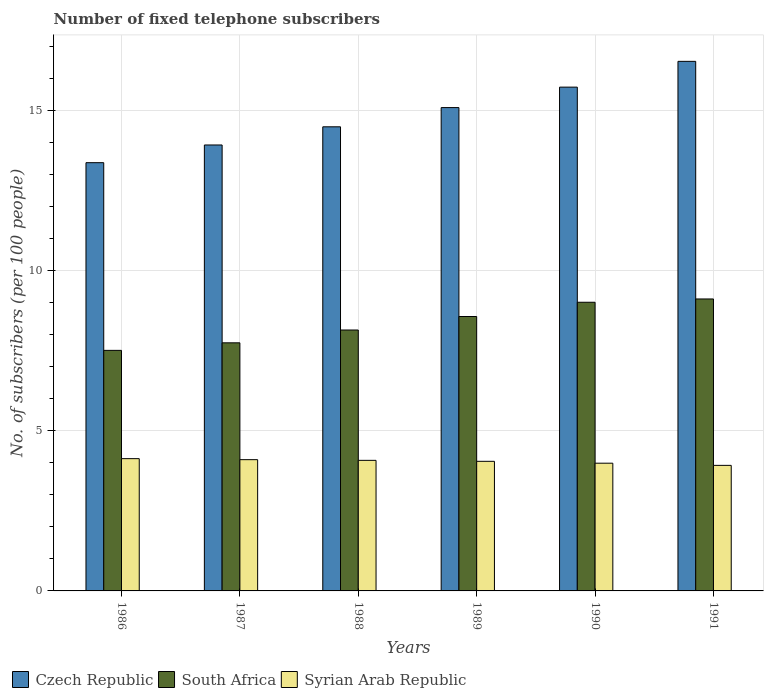How many groups of bars are there?
Provide a short and direct response. 6. What is the number of fixed telephone subscribers in Syrian Arab Republic in 1988?
Your answer should be compact. 4.08. Across all years, what is the maximum number of fixed telephone subscribers in Syrian Arab Republic?
Offer a terse response. 4.13. Across all years, what is the minimum number of fixed telephone subscribers in South Africa?
Ensure brevity in your answer.  7.51. In which year was the number of fixed telephone subscribers in Syrian Arab Republic maximum?
Your answer should be very brief. 1986. In which year was the number of fixed telephone subscribers in South Africa minimum?
Offer a terse response. 1986. What is the total number of fixed telephone subscribers in Syrian Arab Republic in the graph?
Your answer should be very brief. 24.25. What is the difference between the number of fixed telephone subscribers in Syrian Arab Republic in 1987 and that in 1989?
Offer a very short reply. 0.05. What is the difference between the number of fixed telephone subscribers in Czech Republic in 1989 and the number of fixed telephone subscribers in Syrian Arab Republic in 1990?
Your response must be concise. 11.1. What is the average number of fixed telephone subscribers in South Africa per year?
Make the answer very short. 8.35. In the year 1990, what is the difference between the number of fixed telephone subscribers in South Africa and number of fixed telephone subscribers in Czech Republic?
Offer a very short reply. -6.71. What is the ratio of the number of fixed telephone subscribers in Syrian Arab Republic in 1987 to that in 1988?
Provide a short and direct response. 1.01. What is the difference between the highest and the second highest number of fixed telephone subscribers in Czech Republic?
Offer a terse response. 0.8. What is the difference between the highest and the lowest number of fixed telephone subscribers in Czech Republic?
Make the answer very short. 3.16. In how many years, is the number of fixed telephone subscribers in Czech Republic greater than the average number of fixed telephone subscribers in Czech Republic taken over all years?
Provide a succinct answer. 3. What does the 1st bar from the left in 1991 represents?
Make the answer very short. Czech Republic. What does the 2nd bar from the right in 1988 represents?
Offer a terse response. South Africa. Is it the case that in every year, the sum of the number of fixed telephone subscribers in South Africa and number of fixed telephone subscribers in Syrian Arab Republic is greater than the number of fixed telephone subscribers in Czech Republic?
Provide a short and direct response. No. How many bars are there?
Give a very brief answer. 18. How many years are there in the graph?
Ensure brevity in your answer.  6. What is the difference between two consecutive major ticks on the Y-axis?
Keep it short and to the point. 5. Are the values on the major ticks of Y-axis written in scientific E-notation?
Ensure brevity in your answer.  No. Does the graph contain any zero values?
Offer a very short reply. No. Does the graph contain grids?
Your response must be concise. Yes. How many legend labels are there?
Provide a short and direct response. 3. What is the title of the graph?
Give a very brief answer. Number of fixed telephone subscribers. Does "Poland" appear as one of the legend labels in the graph?
Provide a short and direct response. No. What is the label or title of the X-axis?
Offer a terse response. Years. What is the label or title of the Y-axis?
Keep it short and to the point. No. of subscribers (per 100 people). What is the No. of subscribers (per 100 people) of Czech Republic in 1986?
Your response must be concise. 13.37. What is the No. of subscribers (per 100 people) of South Africa in 1986?
Provide a succinct answer. 7.51. What is the No. of subscribers (per 100 people) of Syrian Arab Republic in 1986?
Your answer should be very brief. 4.13. What is the No. of subscribers (per 100 people) of Czech Republic in 1987?
Your answer should be very brief. 13.92. What is the No. of subscribers (per 100 people) in South Africa in 1987?
Ensure brevity in your answer.  7.74. What is the No. of subscribers (per 100 people) of Syrian Arab Republic in 1987?
Provide a short and direct response. 4.1. What is the No. of subscribers (per 100 people) in Czech Republic in 1988?
Provide a short and direct response. 14.49. What is the No. of subscribers (per 100 people) of South Africa in 1988?
Your answer should be very brief. 8.14. What is the No. of subscribers (per 100 people) in Syrian Arab Republic in 1988?
Your answer should be compact. 4.08. What is the No. of subscribers (per 100 people) of Czech Republic in 1989?
Provide a succinct answer. 15.09. What is the No. of subscribers (per 100 people) in South Africa in 1989?
Keep it short and to the point. 8.56. What is the No. of subscribers (per 100 people) of Syrian Arab Republic in 1989?
Ensure brevity in your answer.  4.05. What is the No. of subscribers (per 100 people) in Czech Republic in 1990?
Your answer should be compact. 15.72. What is the No. of subscribers (per 100 people) in South Africa in 1990?
Your answer should be compact. 9.01. What is the No. of subscribers (per 100 people) of Syrian Arab Republic in 1990?
Your response must be concise. 3.99. What is the No. of subscribers (per 100 people) of Czech Republic in 1991?
Your response must be concise. 16.53. What is the No. of subscribers (per 100 people) of South Africa in 1991?
Give a very brief answer. 9.11. What is the No. of subscribers (per 100 people) in Syrian Arab Republic in 1991?
Provide a succinct answer. 3.92. Across all years, what is the maximum No. of subscribers (per 100 people) in Czech Republic?
Give a very brief answer. 16.53. Across all years, what is the maximum No. of subscribers (per 100 people) in South Africa?
Your answer should be compact. 9.11. Across all years, what is the maximum No. of subscribers (per 100 people) of Syrian Arab Republic?
Make the answer very short. 4.13. Across all years, what is the minimum No. of subscribers (per 100 people) in Czech Republic?
Make the answer very short. 13.37. Across all years, what is the minimum No. of subscribers (per 100 people) of South Africa?
Give a very brief answer. 7.51. Across all years, what is the minimum No. of subscribers (per 100 people) of Syrian Arab Republic?
Offer a very short reply. 3.92. What is the total No. of subscribers (per 100 people) in Czech Republic in the graph?
Give a very brief answer. 89.11. What is the total No. of subscribers (per 100 people) in South Africa in the graph?
Offer a terse response. 50.08. What is the total No. of subscribers (per 100 people) in Syrian Arab Republic in the graph?
Make the answer very short. 24.25. What is the difference between the No. of subscribers (per 100 people) in Czech Republic in 1986 and that in 1987?
Give a very brief answer. -0.55. What is the difference between the No. of subscribers (per 100 people) of South Africa in 1986 and that in 1987?
Make the answer very short. -0.24. What is the difference between the No. of subscribers (per 100 people) of Syrian Arab Republic in 1986 and that in 1987?
Provide a short and direct response. 0.03. What is the difference between the No. of subscribers (per 100 people) in Czech Republic in 1986 and that in 1988?
Your answer should be compact. -1.12. What is the difference between the No. of subscribers (per 100 people) in South Africa in 1986 and that in 1988?
Keep it short and to the point. -0.64. What is the difference between the No. of subscribers (per 100 people) of Syrian Arab Republic in 1986 and that in 1988?
Offer a terse response. 0.05. What is the difference between the No. of subscribers (per 100 people) of Czech Republic in 1986 and that in 1989?
Provide a succinct answer. -1.72. What is the difference between the No. of subscribers (per 100 people) of South Africa in 1986 and that in 1989?
Provide a succinct answer. -1.06. What is the difference between the No. of subscribers (per 100 people) of Syrian Arab Republic in 1986 and that in 1989?
Provide a succinct answer. 0.08. What is the difference between the No. of subscribers (per 100 people) in Czech Republic in 1986 and that in 1990?
Ensure brevity in your answer.  -2.36. What is the difference between the No. of subscribers (per 100 people) of South Africa in 1986 and that in 1990?
Your response must be concise. -1.5. What is the difference between the No. of subscribers (per 100 people) in Syrian Arab Republic in 1986 and that in 1990?
Offer a very short reply. 0.14. What is the difference between the No. of subscribers (per 100 people) of Czech Republic in 1986 and that in 1991?
Your answer should be very brief. -3.16. What is the difference between the No. of subscribers (per 100 people) of South Africa in 1986 and that in 1991?
Your answer should be very brief. -1.6. What is the difference between the No. of subscribers (per 100 people) in Syrian Arab Republic in 1986 and that in 1991?
Your answer should be compact. 0.21. What is the difference between the No. of subscribers (per 100 people) of Czech Republic in 1987 and that in 1988?
Offer a terse response. -0.57. What is the difference between the No. of subscribers (per 100 people) in South Africa in 1987 and that in 1988?
Make the answer very short. -0.4. What is the difference between the No. of subscribers (per 100 people) in Syrian Arab Republic in 1987 and that in 1988?
Your response must be concise. 0.02. What is the difference between the No. of subscribers (per 100 people) of Czech Republic in 1987 and that in 1989?
Your response must be concise. -1.17. What is the difference between the No. of subscribers (per 100 people) in South Africa in 1987 and that in 1989?
Provide a succinct answer. -0.82. What is the difference between the No. of subscribers (per 100 people) in Syrian Arab Republic in 1987 and that in 1989?
Keep it short and to the point. 0.05. What is the difference between the No. of subscribers (per 100 people) of Czech Republic in 1987 and that in 1990?
Ensure brevity in your answer.  -1.81. What is the difference between the No. of subscribers (per 100 people) of South Africa in 1987 and that in 1990?
Give a very brief answer. -1.27. What is the difference between the No. of subscribers (per 100 people) in Syrian Arab Republic in 1987 and that in 1990?
Make the answer very short. 0.11. What is the difference between the No. of subscribers (per 100 people) in Czech Republic in 1987 and that in 1991?
Keep it short and to the point. -2.61. What is the difference between the No. of subscribers (per 100 people) in South Africa in 1987 and that in 1991?
Your answer should be very brief. -1.37. What is the difference between the No. of subscribers (per 100 people) of Syrian Arab Republic in 1987 and that in 1991?
Make the answer very short. 0.18. What is the difference between the No. of subscribers (per 100 people) of South Africa in 1988 and that in 1989?
Provide a succinct answer. -0.42. What is the difference between the No. of subscribers (per 100 people) in Syrian Arab Republic in 1988 and that in 1989?
Your response must be concise. 0.03. What is the difference between the No. of subscribers (per 100 people) of Czech Republic in 1988 and that in 1990?
Offer a terse response. -1.24. What is the difference between the No. of subscribers (per 100 people) of South Africa in 1988 and that in 1990?
Keep it short and to the point. -0.87. What is the difference between the No. of subscribers (per 100 people) of Syrian Arab Republic in 1988 and that in 1990?
Your answer should be very brief. 0.09. What is the difference between the No. of subscribers (per 100 people) of Czech Republic in 1988 and that in 1991?
Make the answer very short. -2.04. What is the difference between the No. of subscribers (per 100 people) in South Africa in 1988 and that in 1991?
Offer a very short reply. -0.97. What is the difference between the No. of subscribers (per 100 people) in Syrian Arab Republic in 1988 and that in 1991?
Offer a terse response. 0.16. What is the difference between the No. of subscribers (per 100 people) of Czech Republic in 1989 and that in 1990?
Your answer should be very brief. -0.64. What is the difference between the No. of subscribers (per 100 people) in South Africa in 1989 and that in 1990?
Offer a terse response. -0.44. What is the difference between the No. of subscribers (per 100 people) of Syrian Arab Republic in 1989 and that in 1990?
Ensure brevity in your answer.  0.06. What is the difference between the No. of subscribers (per 100 people) of Czech Republic in 1989 and that in 1991?
Ensure brevity in your answer.  -1.44. What is the difference between the No. of subscribers (per 100 people) in South Africa in 1989 and that in 1991?
Make the answer very short. -0.55. What is the difference between the No. of subscribers (per 100 people) of Syrian Arab Republic in 1989 and that in 1991?
Offer a very short reply. 0.13. What is the difference between the No. of subscribers (per 100 people) in Czech Republic in 1990 and that in 1991?
Provide a succinct answer. -0.8. What is the difference between the No. of subscribers (per 100 people) in South Africa in 1990 and that in 1991?
Offer a very short reply. -0.1. What is the difference between the No. of subscribers (per 100 people) of Syrian Arab Republic in 1990 and that in 1991?
Provide a short and direct response. 0.07. What is the difference between the No. of subscribers (per 100 people) of Czech Republic in 1986 and the No. of subscribers (per 100 people) of South Africa in 1987?
Your answer should be very brief. 5.62. What is the difference between the No. of subscribers (per 100 people) of Czech Republic in 1986 and the No. of subscribers (per 100 people) of Syrian Arab Republic in 1987?
Provide a short and direct response. 9.27. What is the difference between the No. of subscribers (per 100 people) of South Africa in 1986 and the No. of subscribers (per 100 people) of Syrian Arab Republic in 1987?
Your response must be concise. 3.41. What is the difference between the No. of subscribers (per 100 people) of Czech Republic in 1986 and the No. of subscribers (per 100 people) of South Africa in 1988?
Make the answer very short. 5.22. What is the difference between the No. of subscribers (per 100 people) of Czech Republic in 1986 and the No. of subscribers (per 100 people) of Syrian Arab Republic in 1988?
Ensure brevity in your answer.  9.29. What is the difference between the No. of subscribers (per 100 people) in South Africa in 1986 and the No. of subscribers (per 100 people) in Syrian Arab Republic in 1988?
Make the answer very short. 3.43. What is the difference between the No. of subscribers (per 100 people) of Czech Republic in 1986 and the No. of subscribers (per 100 people) of South Africa in 1989?
Make the answer very short. 4.8. What is the difference between the No. of subscribers (per 100 people) in Czech Republic in 1986 and the No. of subscribers (per 100 people) in Syrian Arab Republic in 1989?
Offer a terse response. 9.32. What is the difference between the No. of subscribers (per 100 people) of South Africa in 1986 and the No. of subscribers (per 100 people) of Syrian Arab Republic in 1989?
Offer a very short reply. 3.46. What is the difference between the No. of subscribers (per 100 people) in Czech Republic in 1986 and the No. of subscribers (per 100 people) in South Africa in 1990?
Your answer should be very brief. 4.36. What is the difference between the No. of subscribers (per 100 people) in Czech Republic in 1986 and the No. of subscribers (per 100 people) in Syrian Arab Republic in 1990?
Offer a very short reply. 9.38. What is the difference between the No. of subscribers (per 100 people) in South Africa in 1986 and the No. of subscribers (per 100 people) in Syrian Arab Republic in 1990?
Make the answer very short. 3.52. What is the difference between the No. of subscribers (per 100 people) of Czech Republic in 1986 and the No. of subscribers (per 100 people) of South Africa in 1991?
Give a very brief answer. 4.25. What is the difference between the No. of subscribers (per 100 people) in Czech Republic in 1986 and the No. of subscribers (per 100 people) in Syrian Arab Republic in 1991?
Keep it short and to the point. 9.45. What is the difference between the No. of subscribers (per 100 people) in South Africa in 1986 and the No. of subscribers (per 100 people) in Syrian Arab Republic in 1991?
Provide a succinct answer. 3.59. What is the difference between the No. of subscribers (per 100 people) of Czech Republic in 1987 and the No. of subscribers (per 100 people) of South Africa in 1988?
Offer a terse response. 5.78. What is the difference between the No. of subscribers (per 100 people) of Czech Republic in 1987 and the No. of subscribers (per 100 people) of Syrian Arab Republic in 1988?
Offer a very short reply. 9.84. What is the difference between the No. of subscribers (per 100 people) in South Africa in 1987 and the No. of subscribers (per 100 people) in Syrian Arab Republic in 1988?
Your answer should be very brief. 3.67. What is the difference between the No. of subscribers (per 100 people) of Czech Republic in 1987 and the No. of subscribers (per 100 people) of South Africa in 1989?
Give a very brief answer. 5.35. What is the difference between the No. of subscribers (per 100 people) in Czech Republic in 1987 and the No. of subscribers (per 100 people) in Syrian Arab Republic in 1989?
Make the answer very short. 9.87. What is the difference between the No. of subscribers (per 100 people) of South Africa in 1987 and the No. of subscribers (per 100 people) of Syrian Arab Republic in 1989?
Offer a very short reply. 3.7. What is the difference between the No. of subscribers (per 100 people) of Czech Republic in 1987 and the No. of subscribers (per 100 people) of South Africa in 1990?
Ensure brevity in your answer.  4.91. What is the difference between the No. of subscribers (per 100 people) in Czech Republic in 1987 and the No. of subscribers (per 100 people) in Syrian Arab Republic in 1990?
Provide a short and direct response. 9.93. What is the difference between the No. of subscribers (per 100 people) in South Africa in 1987 and the No. of subscribers (per 100 people) in Syrian Arab Republic in 1990?
Your response must be concise. 3.76. What is the difference between the No. of subscribers (per 100 people) of Czech Republic in 1987 and the No. of subscribers (per 100 people) of South Africa in 1991?
Give a very brief answer. 4.81. What is the difference between the No. of subscribers (per 100 people) of Czech Republic in 1987 and the No. of subscribers (per 100 people) of Syrian Arab Republic in 1991?
Ensure brevity in your answer.  10. What is the difference between the No. of subscribers (per 100 people) of South Africa in 1987 and the No. of subscribers (per 100 people) of Syrian Arab Republic in 1991?
Ensure brevity in your answer.  3.82. What is the difference between the No. of subscribers (per 100 people) in Czech Republic in 1988 and the No. of subscribers (per 100 people) in South Africa in 1989?
Offer a very short reply. 5.92. What is the difference between the No. of subscribers (per 100 people) of Czech Republic in 1988 and the No. of subscribers (per 100 people) of Syrian Arab Republic in 1989?
Keep it short and to the point. 10.44. What is the difference between the No. of subscribers (per 100 people) in South Africa in 1988 and the No. of subscribers (per 100 people) in Syrian Arab Republic in 1989?
Your answer should be very brief. 4.1. What is the difference between the No. of subscribers (per 100 people) of Czech Republic in 1988 and the No. of subscribers (per 100 people) of South Africa in 1990?
Provide a short and direct response. 5.48. What is the difference between the No. of subscribers (per 100 people) of Czech Republic in 1988 and the No. of subscribers (per 100 people) of Syrian Arab Republic in 1990?
Keep it short and to the point. 10.5. What is the difference between the No. of subscribers (per 100 people) of South Africa in 1988 and the No. of subscribers (per 100 people) of Syrian Arab Republic in 1990?
Offer a very short reply. 4.16. What is the difference between the No. of subscribers (per 100 people) of Czech Republic in 1988 and the No. of subscribers (per 100 people) of South Africa in 1991?
Your answer should be very brief. 5.37. What is the difference between the No. of subscribers (per 100 people) in Czech Republic in 1988 and the No. of subscribers (per 100 people) in Syrian Arab Republic in 1991?
Offer a very short reply. 10.57. What is the difference between the No. of subscribers (per 100 people) of South Africa in 1988 and the No. of subscribers (per 100 people) of Syrian Arab Republic in 1991?
Make the answer very short. 4.22. What is the difference between the No. of subscribers (per 100 people) of Czech Republic in 1989 and the No. of subscribers (per 100 people) of South Africa in 1990?
Give a very brief answer. 6.08. What is the difference between the No. of subscribers (per 100 people) of Czech Republic in 1989 and the No. of subscribers (per 100 people) of Syrian Arab Republic in 1990?
Give a very brief answer. 11.1. What is the difference between the No. of subscribers (per 100 people) in South Africa in 1989 and the No. of subscribers (per 100 people) in Syrian Arab Republic in 1990?
Offer a very short reply. 4.58. What is the difference between the No. of subscribers (per 100 people) in Czech Republic in 1989 and the No. of subscribers (per 100 people) in South Africa in 1991?
Your response must be concise. 5.97. What is the difference between the No. of subscribers (per 100 people) of Czech Republic in 1989 and the No. of subscribers (per 100 people) of Syrian Arab Republic in 1991?
Provide a succinct answer. 11.17. What is the difference between the No. of subscribers (per 100 people) in South Africa in 1989 and the No. of subscribers (per 100 people) in Syrian Arab Republic in 1991?
Provide a short and direct response. 4.65. What is the difference between the No. of subscribers (per 100 people) in Czech Republic in 1990 and the No. of subscribers (per 100 people) in South Africa in 1991?
Ensure brevity in your answer.  6.61. What is the difference between the No. of subscribers (per 100 people) in Czech Republic in 1990 and the No. of subscribers (per 100 people) in Syrian Arab Republic in 1991?
Keep it short and to the point. 11.81. What is the difference between the No. of subscribers (per 100 people) in South Africa in 1990 and the No. of subscribers (per 100 people) in Syrian Arab Republic in 1991?
Ensure brevity in your answer.  5.09. What is the average No. of subscribers (per 100 people) in Czech Republic per year?
Your answer should be compact. 14.85. What is the average No. of subscribers (per 100 people) in South Africa per year?
Make the answer very short. 8.35. What is the average No. of subscribers (per 100 people) of Syrian Arab Republic per year?
Your answer should be compact. 4.04. In the year 1986, what is the difference between the No. of subscribers (per 100 people) in Czech Republic and No. of subscribers (per 100 people) in South Africa?
Make the answer very short. 5.86. In the year 1986, what is the difference between the No. of subscribers (per 100 people) of Czech Republic and No. of subscribers (per 100 people) of Syrian Arab Republic?
Your answer should be very brief. 9.24. In the year 1986, what is the difference between the No. of subscribers (per 100 people) of South Africa and No. of subscribers (per 100 people) of Syrian Arab Republic?
Offer a terse response. 3.38. In the year 1987, what is the difference between the No. of subscribers (per 100 people) of Czech Republic and No. of subscribers (per 100 people) of South Africa?
Offer a terse response. 6.17. In the year 1987, what is the difference between the No. of subscribers (per 100 people) in Czech Republic and No. of subscribers (per 100 people) in Syrian Arab Republic?
Your answer should be very brief. 9.82. In the year 1987, what is the difference between the No. of subscribers (per 100 people) of South Africa and No. of subscribers (per 100 people) of Syrian Arab Republic?
Provide a short and direct response. 3.65. In the year 1988, what is the difference between the No. of subscribers (per 100 people) of Czech Republic and No. of subscribers (per 100 people) of South Africa?
Your answer should be very brief. 6.34. In the year 1988, what is the difference between the No. of subscribers (per 100 people) in Czech Republic and No. of subscribers (per 100 people) in Syrian Arab Republic?
Provide a succinct answer. 10.41. In the year 1988, what is the difference between the No. of subscribers (per 100 people) of South Africa and No. of subscribers (per 100 people) of Syrian Arab Republic?
Your response must be concise. 4.07. In the year 1989, what is the difference between the No. of subscribers (per 100 people) of Czech Republic and No. of subscribers (per 100 people) of South Africa?
Keep it short and to the point. 6.52. In the year 1989, what is the difference between the No. of subscribers (per 100 people) of Czech Republic and No. of subscribers (per 100 people) of Syrian Arab Republic?
Give a very brief answer. 11.04. In the year 1989, what is the difference between the No. of subscribers (per 100 people) of South Africa and No. of subscribers (per 100 people) of Syrian Arab Republic?
Keep it short and to the point. 4.52. In the year 1990, what is the difference between the No. of subscribers (per 100 people) of Czech Republic and No. of subscribers (per 100 people) of South Africa?
Your answer should be compact. 6.71. In the year 1990, what is the difference between the No. of subscribers (per 100 people) of Czech Republic and No. of subscribers (per 100 people) of Syrian Arab Republic?
Ensure brevity in your answer.  11.74. In the year 1990, what is the difference between the No. of subscribers (per 100 people) of South Africa and No. of subscribers (per 100 people) of Syrian Arab Republic?
Make the answer very short. 5.02. In the year 1991, what is the difference between the No. of subscribers (per 100 people) in Czech Republic and No. of subscribers (per 100 people) in South Africa?
Ensure brevity in your answer.  7.42. In the year 1991, what is the difference between the No. of subscribers (per 100 people) in Czech Republic and No. of subscribers (per 100 people) in Syrian Arab Republic?
Ensure brevity in your answer.  12.61. In the year 1991, what is the difference between the No. of subscribers (per 100 people) in South Africa and No. of subscribers (per 100 people) in Syrian Arab Republic?
Your answer should be compact. 5.19. What is the ratio of the No. of subscribers (per 100 people) of Czech Republic in 1986 to that in 1987?
Provide a succinct answer. 0.96. What is the ratio of the No. of subscribers (per 100 people) in South Africa in 1986 to that in 1987?
Your answer should be very brief. 0.97. What is the ratio of the No. of subscribers (per 100 people) in Syrian Arab Republic in 1986 to that in 1987?
Give a very brief answer. 1.01. What is the ratio of the No. of subscribers (per 100 people) in Czech Republic in 1986 to that in 1988?
Provide a succinct answer. 0.92. What is the ratio of the No. of subscribers (per 100 people) of South Africa in 1986 to that in 1988?
Your response must be concise. 0.92. What is the ratio of the No. of subscribers (per 100 people) of Syrian Arab Republic in 1986 to that in 1988?
Provide a succinct answer. 1.01. What is the ratio of the No. of subscribers (per 100 people) in Czech Republic in 1986 to that in 1989?
Offer a terse response. 0.89. What is the ratio of the No. of subscribers (per 100 people) of South Africa in 1986 to that in 1989?
Your answer should be very brief. 0.88. What is the ratio of the No. of subscribers (per 100 people) of Syrian Arab Republic in 1986 to that in 1989?
Keep it short and to the point. 1.02. What is the ratio of the No. of subscribers (per 100 people) in Czech Republic in 1986 to that in 1990?
Keep it short and to the point. 0.85. What is the ratio of the No. of subscribers (per 100 people) of South Africa in 1986 to that in 1990?
Ensure brevity in your answer.  0.83. What is the ratio of the No. of subscribers (per 100 people) in Syrian Arab Republic in 1986 to that in 1990?
Offer a terse response. 1.04. What is the ratio of the No. of subscribers (per 100 people) of Czech Republic in 1986 to that in 1991?
Provide a succinct answer. 0.81. What is the ratio of the No. of subscribers (per 100 people) in South Africa in 1986 to that in 1991?
Provide a short and direct response. 0.82. What is the ratio of the No. of subscribers (per 100 people) in Syrian Arab Republic in 1986 to that in 1991?
Your response must be concise. 1.05. What is the ratio of the No. of subscribers (per 100 people) of Czech Republic in 1987 to that in 1988?
Offer a very short reply. 0.96. What is the ratio of the No. of subscribers (per 100 people) of South Africa in 1987 to that in 1988?
Your answer should be very brief. 0.95. What is the ratio of the No. of subscribers (per 100 people) of Syrian Arab Republic in 1987 to that in 1988?
Make the answer very short. 1.01. What is the ratio of the No. of subscribers (per 100 people) in Czech Republic in 1987 to that in 1989?
Provide a short and direct response. 0.92. What is the ratio of the No. of subscribers (per 100 people) in South Africa in 1987 to that in 1989?
Keep it short and to the point. 0.9. What is the ratio of the No. of subscribers (per 100 people) in Syrian Arab Republic in 1987 to that in 1989?
Offer a terse response. 1.01. What is the ratio of the No. of subscribers (per 100 people) of Czech Republic in 1987 to that in 1990?
Your response must be concise. 0.89. What is the ratio of the No. of subscribers (per 100 people) of South Africa in 1987 to that in 1990?
Provide a succinct answer. 0.86. What is the ratio of the No. of subscribers (per 100 people) in Syrian Arab Republic in 1987 to that in 1990?
Give a very brief answer. 1.03. What is the ratio of the No. of subscribers (per 100 people) of Czech Republic in 1987 to that in 1991?
Your answer should be very brief. 0.84. What is the ratio of the No. of subscribers (per 100 people) in South Africa in 1987 to that in 1991?
Ensure brevity in your answer.  0.85. What is the ratio of the No. of subscribers (per 100 people) of Syrian Arab Republic in 1987 to that in 1991?
Your answer should be very brief. 1.05. What is the ratio of the No. of subscribers (per 100 people) in Czech Republic in 1988 to that in 1989?
Keep it short and to the point. 0.96. What is the ratio of the No. of subscribers (per 100 people) of South Africa in 1988 to that in 1989?
Give a very brief answer. 0.95. What is the ratio of the No. of subscribers (per 100 people) in Syrian Arab Republic in 1988 to that in 1989?
Offer a very short reply. 1.01. What is the ratio of the No. of subscribers (per 100 people) of Czech Republic in 1988 to that in 1990?
Ensure brevity in your answer.  0.92. What is the ratio of the No. of subscribers (per 100 people) in South Africa in 1988 to that in 1990?
Offer a very short reply. 0.9. What is the ratio of the No. of subscribers (per 100 people) in Syrian Arab Republic in 1988 to that in 1990?
Offer a terse response. 1.02. What is the ratio of the No. of subscribers (per 100 people) in Czech Republic in 1988 to that in 1991?
Make the answer very short. 0.88. What is the ratio of the No. of subscribers (per 100 people) in South Africa in 1988 to that in 1991?
Your answer should be compact. 0.89. What is the ratio of the No. of subscribers (per 100 people) of Syrian Arab Republic in 1988 to that in 1991?
Ensure brevity in your answer.  1.04. What is the ratio of the No. of subscribers (per 100 people) in Czech Republic in 1989 to that in 1990?
Give a very brief answer. 0.96. What is the ratio of the No. of subscribers (per 100 people) of South Africa in 1989 to that in 1990?
Give a very brief answer. 0.95. What is the ratio of the No. of subscribers (per 100 people) of Syrian Arab Republic in 1989 to that in 1990?
Ensure brevity in your answer.  1.01. What is the ratio of the No. of subscribers (per 100 people) in Czech Republic in 1989 to that in 1991?
Your response must be concise. 0.91. What is the ratio of the No. of subscribers (per 100 people) in South Africa in 1989 to that in 1991?
Your answer should be very brief. 0.94. What is the ratio of the No. of subscribers (per 100 people) of Syrian Arab Republic in 1989 to that in 1991?
Provide a succinct answer. 1.03. What is the ratio of the No. of subscribers (per 100 people) of Czech Republic in 1990 to that in 1991?
Your response must be concise. 0.95. What is the ratio of the No. of subscribers (per 100 people) of South Africa in 1990 to that in 1991?
Give a very brief answer. 0.99. What is the ratio of the No. of subscribers (per 100 people) in Syrian Arab Republic in 1990 to that in 1991?
Provide a succinct answer. 1.02. What is the difference between the highest and the second highest No. of subscribers (per 100 people) in Czech Republic?
Give a very brief answer. 0.8. What is the difference between the highest and the second highest No. of subscribers (per 100 people) of South Africa?
Ensure brevity in your answer.  0.1. What is the difference between the highest and the second highest No. of subscribers (per 100 people) of Syrian Arab Republic?
Your answer should be very brief. 0.03. What is the difference between the highest and the lowest No. of subscribers (per 100 people) in Czech Republic?
Make the answer very short. 3.16. What is the difference between the highest and the lowest No. of subscribers (per 100 people) of South Africa?
Your answer should be very brief. 1.6. What is the difference between the highest and the lowest No. of subscribers (per 100 people) in Syrian Arab Republic?
Provide a succinct answer. 0.21. 